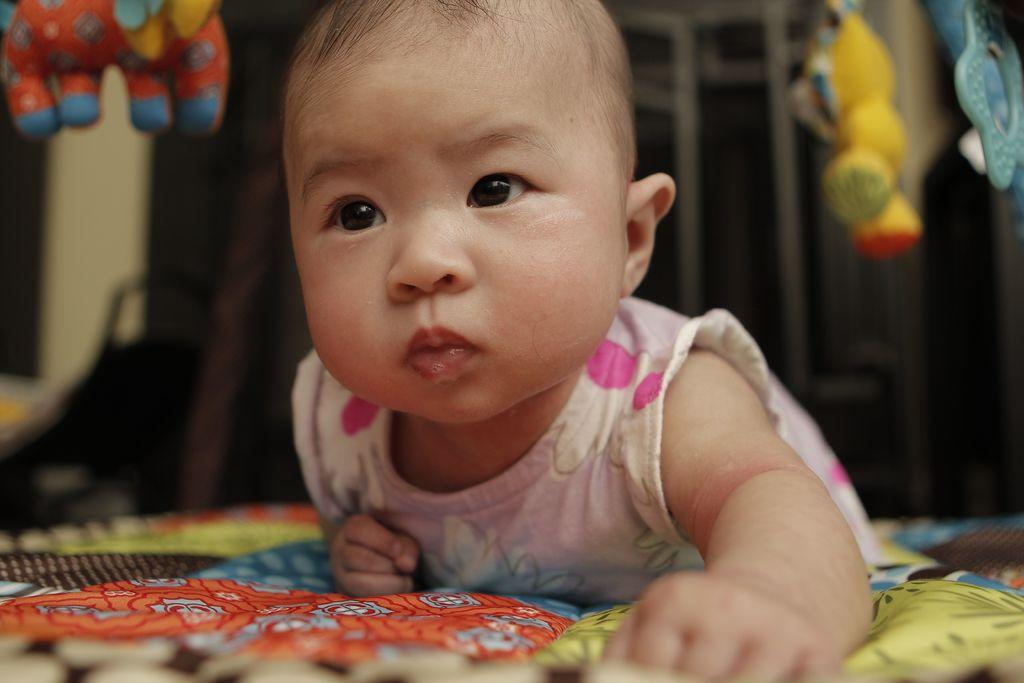What is the main subject of the image? There is a baby in the image. Where is the baby located? The baby is laying on a bed sheet. What else can be seen in the image besides the baby? There are toys in the image. Can you describe the background of the image? The background of the image is blurred. What type of dress is the baby wearing in the image? The baby is not wearing a dress in the image; they are laying on a bed sheet. How does the baby lead the toys in the image? The baby is not leading the toys in the image; they are simply laying on a bed sheet with toys nearby. 